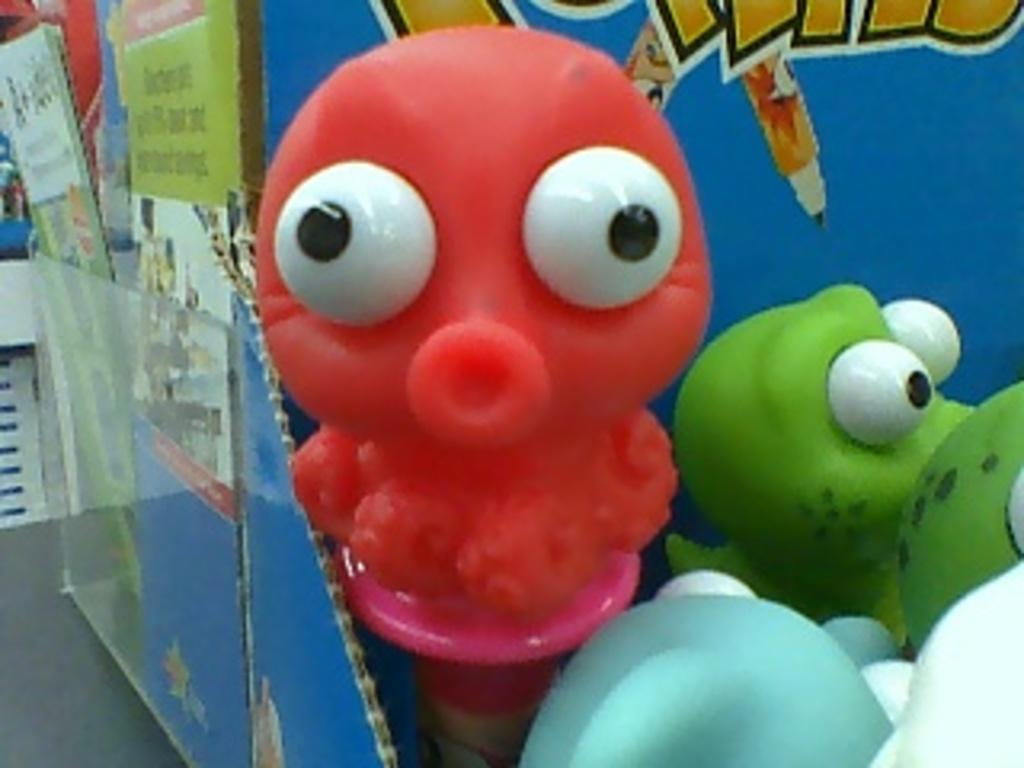What objects are in the center of the image? There are toys in the center of the image. What can be seen in the background of the image? There is a board in the background of the image. What type of record is being played in the image? There is no record player or record visible in the image. 